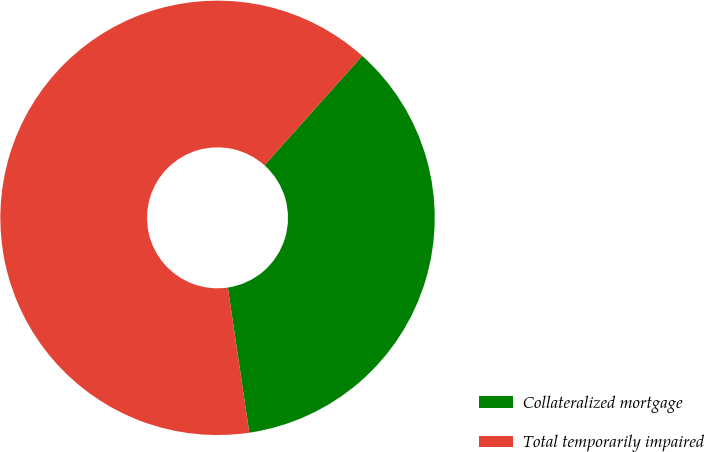Convert chart to OTSL. <chart><loc_0><loc_0><loc_500><loc_500><pie_chart><fcel>Collateralized mortgage<fcel>Total temporarily impaired<nl><fcel>36.06%<fcel>63.94%<nl></chart> 